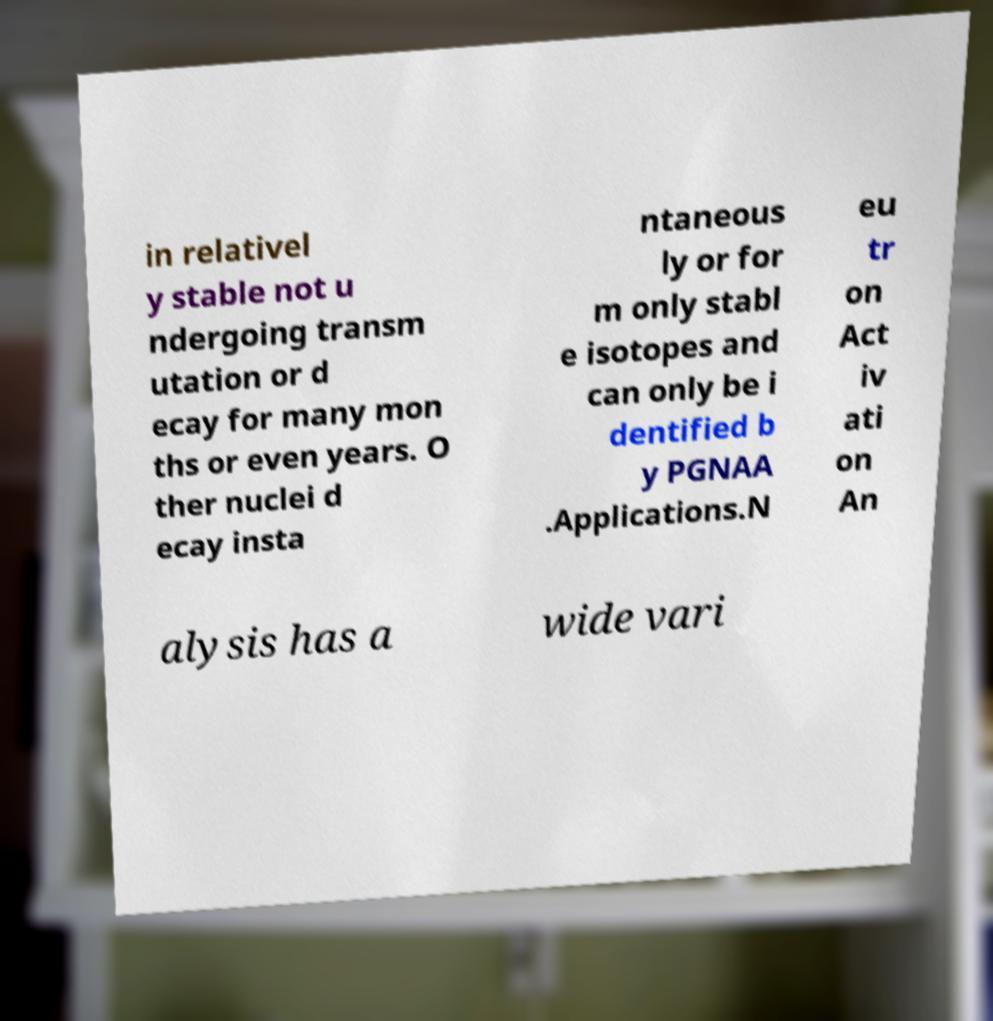For documentation purposes, I need the text within this image transcribed. Could you provide that? in relativel y stable not u ndergoing transm utation or d ecay for many mon ths or even years. O ther nuclei d ecay insta ntaneous ly or for m only stabl e isotopes and can only be i dentified b y PGNAA .Applications.N eu tr on Act iv ati on An alysis has a wide vari 